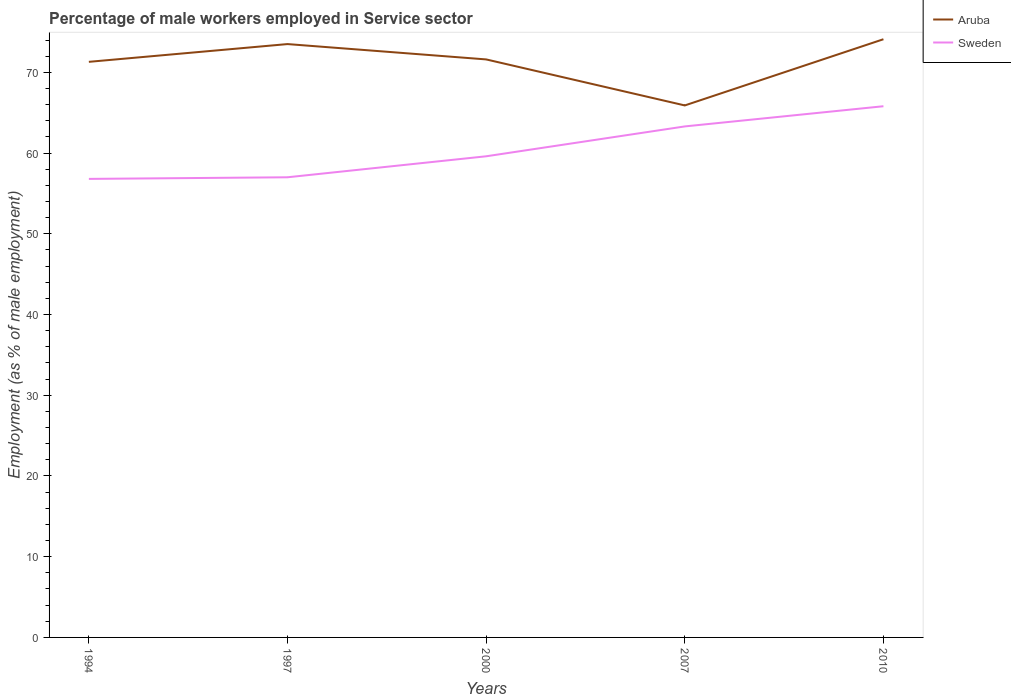How many different coloured lines are there?
Keep it short and to the point. 2. Does the line corresponding to Sweden intersect with the line corresponding to Aruba?
Keep it short and to the point. No. Is the number of lines equal to the number of legend labels?
Offer a very short reply. Yes. Across all years, what is the maximum percentage of male workers employed in Service sector in Sweden?
Your response must be concise. 56.8. What is the total percentage of male workers employed in Service sector in Sweden in the graph?
Your answer should be very brief. -2.8. What is the difference between the highest and the second highest percentage of male workers employed in Service sector in Sweden?
Keep it short and to the point. 9. What is the difference between the highest and the lowest percentage of male workers employed in Service sector in Aruba?
Your answer should be compact. 4. Is the percentage of male workers employed in Service sector in Sweden strictly greater than the percentage of male workers employed in Service sector in Aruba over the years?
Provide a succinct answer. Yes. How many lines are there?
Your response must be concise. 2. How many years are there in the graph?
Your response must be concise. 5. Are the values on the major ticks of Y-axis written in scientific E-notation?
Your answer should be very brief. No. How are the legend labels stacked?
Your answer should be very brief. Vertical. What is the title of the graph?
Your response must be concise. Percentage of male workers employed in Service sector. Does "Malawi" appear as one of the legend labels in the graph?
Offer a very short reply. No. What is the label or title of the X-axis?
Offer a very short reply. Years. What is the label or title of the Y-axis?
Make the answer very short. Employment (as % of male employment). What is the Employment (as % of male employment) of Aruba in 1994?
Offer a very short reply. 71.3. What is the Employment (as % of male employment) of Sweden in 1994?
Your answer should be compact. 56.8. What is the Employment (as % of male employment) of Aruba in 1997?
Offer a very short reply. 73.5. What is the Employment (as % of male employment) of Aruba in 2000?
Provide a short and direct response. 71.6. What is the Employment (as % of male employment) of Sweden in 2000?
Provide a short and direct response. 59.6. What is the Employment (as % of male employment) of Aruba in 2007?
Your response must be concise. 65.9. What is the Employment (as % of male employment) of Sweden in 2007?
Give a very brief answer. 63.3. What is the Employment (as % of male employment) in Aruba in 2010?
Your answer should be very brief. 74.1. What is the Employment (as % of male employment) of Sweden in 2010?
Ensure brevity in your answer.  65.8. Across all years, what is the maximum Employment (as % of male employment) of Aruba?
Your answer should be compact. 74.1. Across all years, what is the maximum Employment (as % of male employment) in Sweden?
Provide a short and direct response. 65.8. Across all years, what is the minimum Employment (as % of male employment) of Aruba?
Offer a terse response. 65.9. Across all years, what is the minimum Employment (as % of male employment) in Sweden?
Make the answer very short. 56.8. What is the total Employment (as % of male employment) of Aruba in the graph?
Make the answer very short. 356.4. What is the total Employment (as % of male employment) of Sweden in the graph?
Give a very brief answer. 302.5. What is the difference between the Employment (as % of male employment) of Aruba in 1994 and that in 1997?
Your response must be concise. -2.2. What is the difference between the Employment (as % of male employment) of Sweden in 1994 and that in 1997?
Keep it short and to the point. -0.2. What is the difference between the Employment (as % of male employment) of Aruba in 1994 and that in 2000?
Ensure brevity in your answer.  -0.3. What is the difference between the Employment (as % of male employment) in Aruba in 1994 and that in 2007?
Ensure brevity in your answer.  5.4. What is the difference between the Employment (as % of male employment) in Sweden in 1997 and that in 2000?
Offer a terse response. -2.6. What is the difference between the Employment (as % of male employment) of Sweden in 1997 and that in 2007?
Ensure brevity in your answer.  -6.3. What is the difference between the Employment (as % of male employment) in Aruba in 1997 and that in 2010?
Your answer should be very brief. -0.6. What is the difference between the Employment (as % of male employment) of Sweden in 1997 and that in 2010?
Give a very brief answer. -8.8. What is the difference between the Employment (as % of male employment) in Aruba in 2000 and that in 2010?
Keep it short and to the point. -2.5. What is the difference between the Employment (as % of male employment) of Sweden in 2000 and that in 2010?
Offer a very short reply. -6.2. What is the difference between the Employment (as % of male employment) of Aruba in 1997 and the Employment (as % of male employment) of Sweden in 2000?
Offer a terse response. 13.9. What is the difference between the Employment (as % of male employment) of Aruba in 2007 and the Employment (as % of male employment) of Sweden in 2010?
Make the answer very short. 0.1. What is the average Employment (as % of male employment) of Aruba per year?
Your response must be concise. 71.28. What is the average Employment (as % of male employment) of Sweden per year?
Ensure brevity in your answer.  60.5. In the year 2007, what is the difference between the Employment (as % of male employment) in Aruba and Employment (as % of male employment) in Sweden?
Ensure brevity in your answer.  2.6. What is the ratio of the Employment (as % of male employment) of Aruba in 1994 to that in 1997?
Ensure brevity in your answer.  0.97. What is the ratio of the Employment (as % of male employment) of Sweden in 1994 to that in 1997?
Ensure brevity in your answer.  1. What is the ratio of the Employment (as % of male employment) in Aruba in 1994 to that in 2000?
Keep it short and to the point. 1. What is the ratio of the Employment (as % of male employment) of Sweden in 1994 to that in 2000?
Keep it short and to the point. 0.95. What is the ratio of the Employment (as % of male employment) of Aruba in 1994 to that in 2007?
Ensure brevity in your answer.  1.08. What is the ratio of the Employment (as % of male employment) of Sweden in 1994 to that in 2007?
Your answer should be compact. 0.9. What is the ratio of the Employment (as % of male employment) of Aruba in 1994 to that in 2010?
Provide a short and direct response. 0.96. What is the ratio of the Employment (as % of male employment) of Sweden in 1994 to that in 2010?
Offer a terse response. 0.86. What is the ratio of the Employment (as % of male employment) of Aruba in 1997 to that in 2000?
Give a very brief answer. 1.03. What is the ratio of the Employment (as % of male employment) in Sweden in 1997 to that in 2000?
Your answer should be very brief. 0.96. What is the ratio of the Employment (as % of male employment) in Aruba in 1997 to that in 2007?
Your answer should be very brief. 1.12. What is the ratio of the Employment (as % of male employment) of Sweden in 1997 to that in 2007?
Offer a terse response. 0.9. What is the ratio of the Employment (as % of male employment) in Aruba in 1997 to that in 2010?
Provide a succinct answer. 0.99. What is the ratio of the Employment (as % of male employment) in Sweden in 1997 to that in 2010?
Provide a succinct answer. 0.87. What is the ratio of the Employment (as % of male employment) in Aruba in 2000 to that in 2007?
Provide a short and direct response. 1.09. What is the ratio of the Employment (as % of male employment) of Sweden in 2000 to that in 2007?
Offer a very short reply. 0.94. What is the ratio of the Employment (as % of male employment) in Aruba in 2000 to that in 2010?
Give a very brief answer. 0.97. What is the ratio of the Employment (as % of male employment) in Sweden in 2000 to that in 2010?
Offer a terse response. 0.91. What is the ratio of the Employment (as % of male employment) of Aruba in 2007 to that in 2010?
Keep it short and to the point. 0.89. What is the ratio of the Employment (as % of male employment) in Sweden in 2007 to that in 2010?
Offer a very short reply. 0.96. What is the difference between the highest and the lowest Employment (as % of male employment) of Sweden?
Your answer should be compact. 9. 